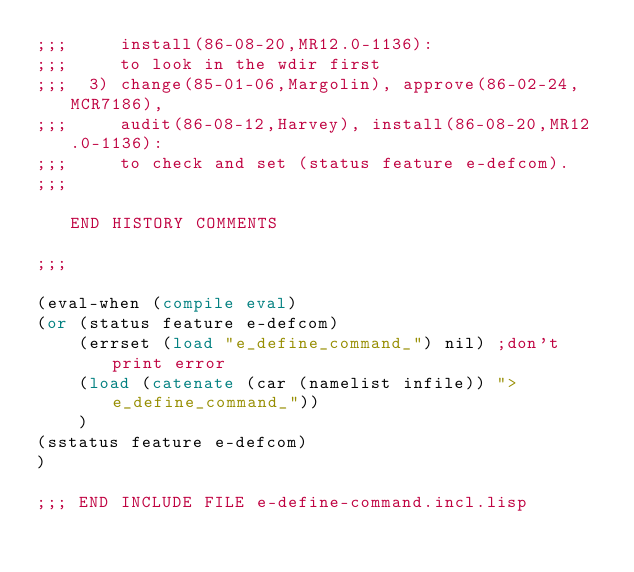<code> <loc_0><loc_0><loc_500><loc_500><_Lisp_>;;;     install(86-08-20,MR12.0-1136):
;;;     to look in the wdir first
;;;  3) change(85-01-06,Margolin), approve(86-02-24,MCR7186),
;;;     audit(86-08-12,Harvey), install(86-08-20,MR12.0-1136):
;;;     to check and set (status feature e-defcom).
;;;                                                      END HISTORY COMMENTS

;;;

(eval-when (compile eval)
(or (status feature e-defcom)
    (errset (load "e_define_command_") nil)	;don't print error
    (load (catenate (car (namelist infile)) ">e_define_command_"))
    )
(sstatus feature e-defcom)
)

;;; END INCLUDE FILE e-define-command.incl.lisp
</code> 